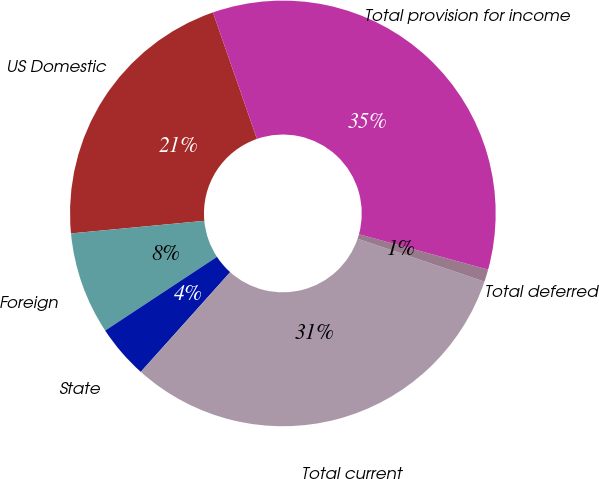Convert chart. <chart><loc_0><loc_0><loc_500><loc_500><pie_chart><fcel>US Domestic<fcel>Foreign<fcel>State<fcel>Total current<fcel>Total deferred<fcel>Total provision for income<nl><fcel>21.17%<fcel>7.78%<fcel>4.09%<fcel>31.44%<fcel>0.94%<fcel>34.58%<nl></chart> 